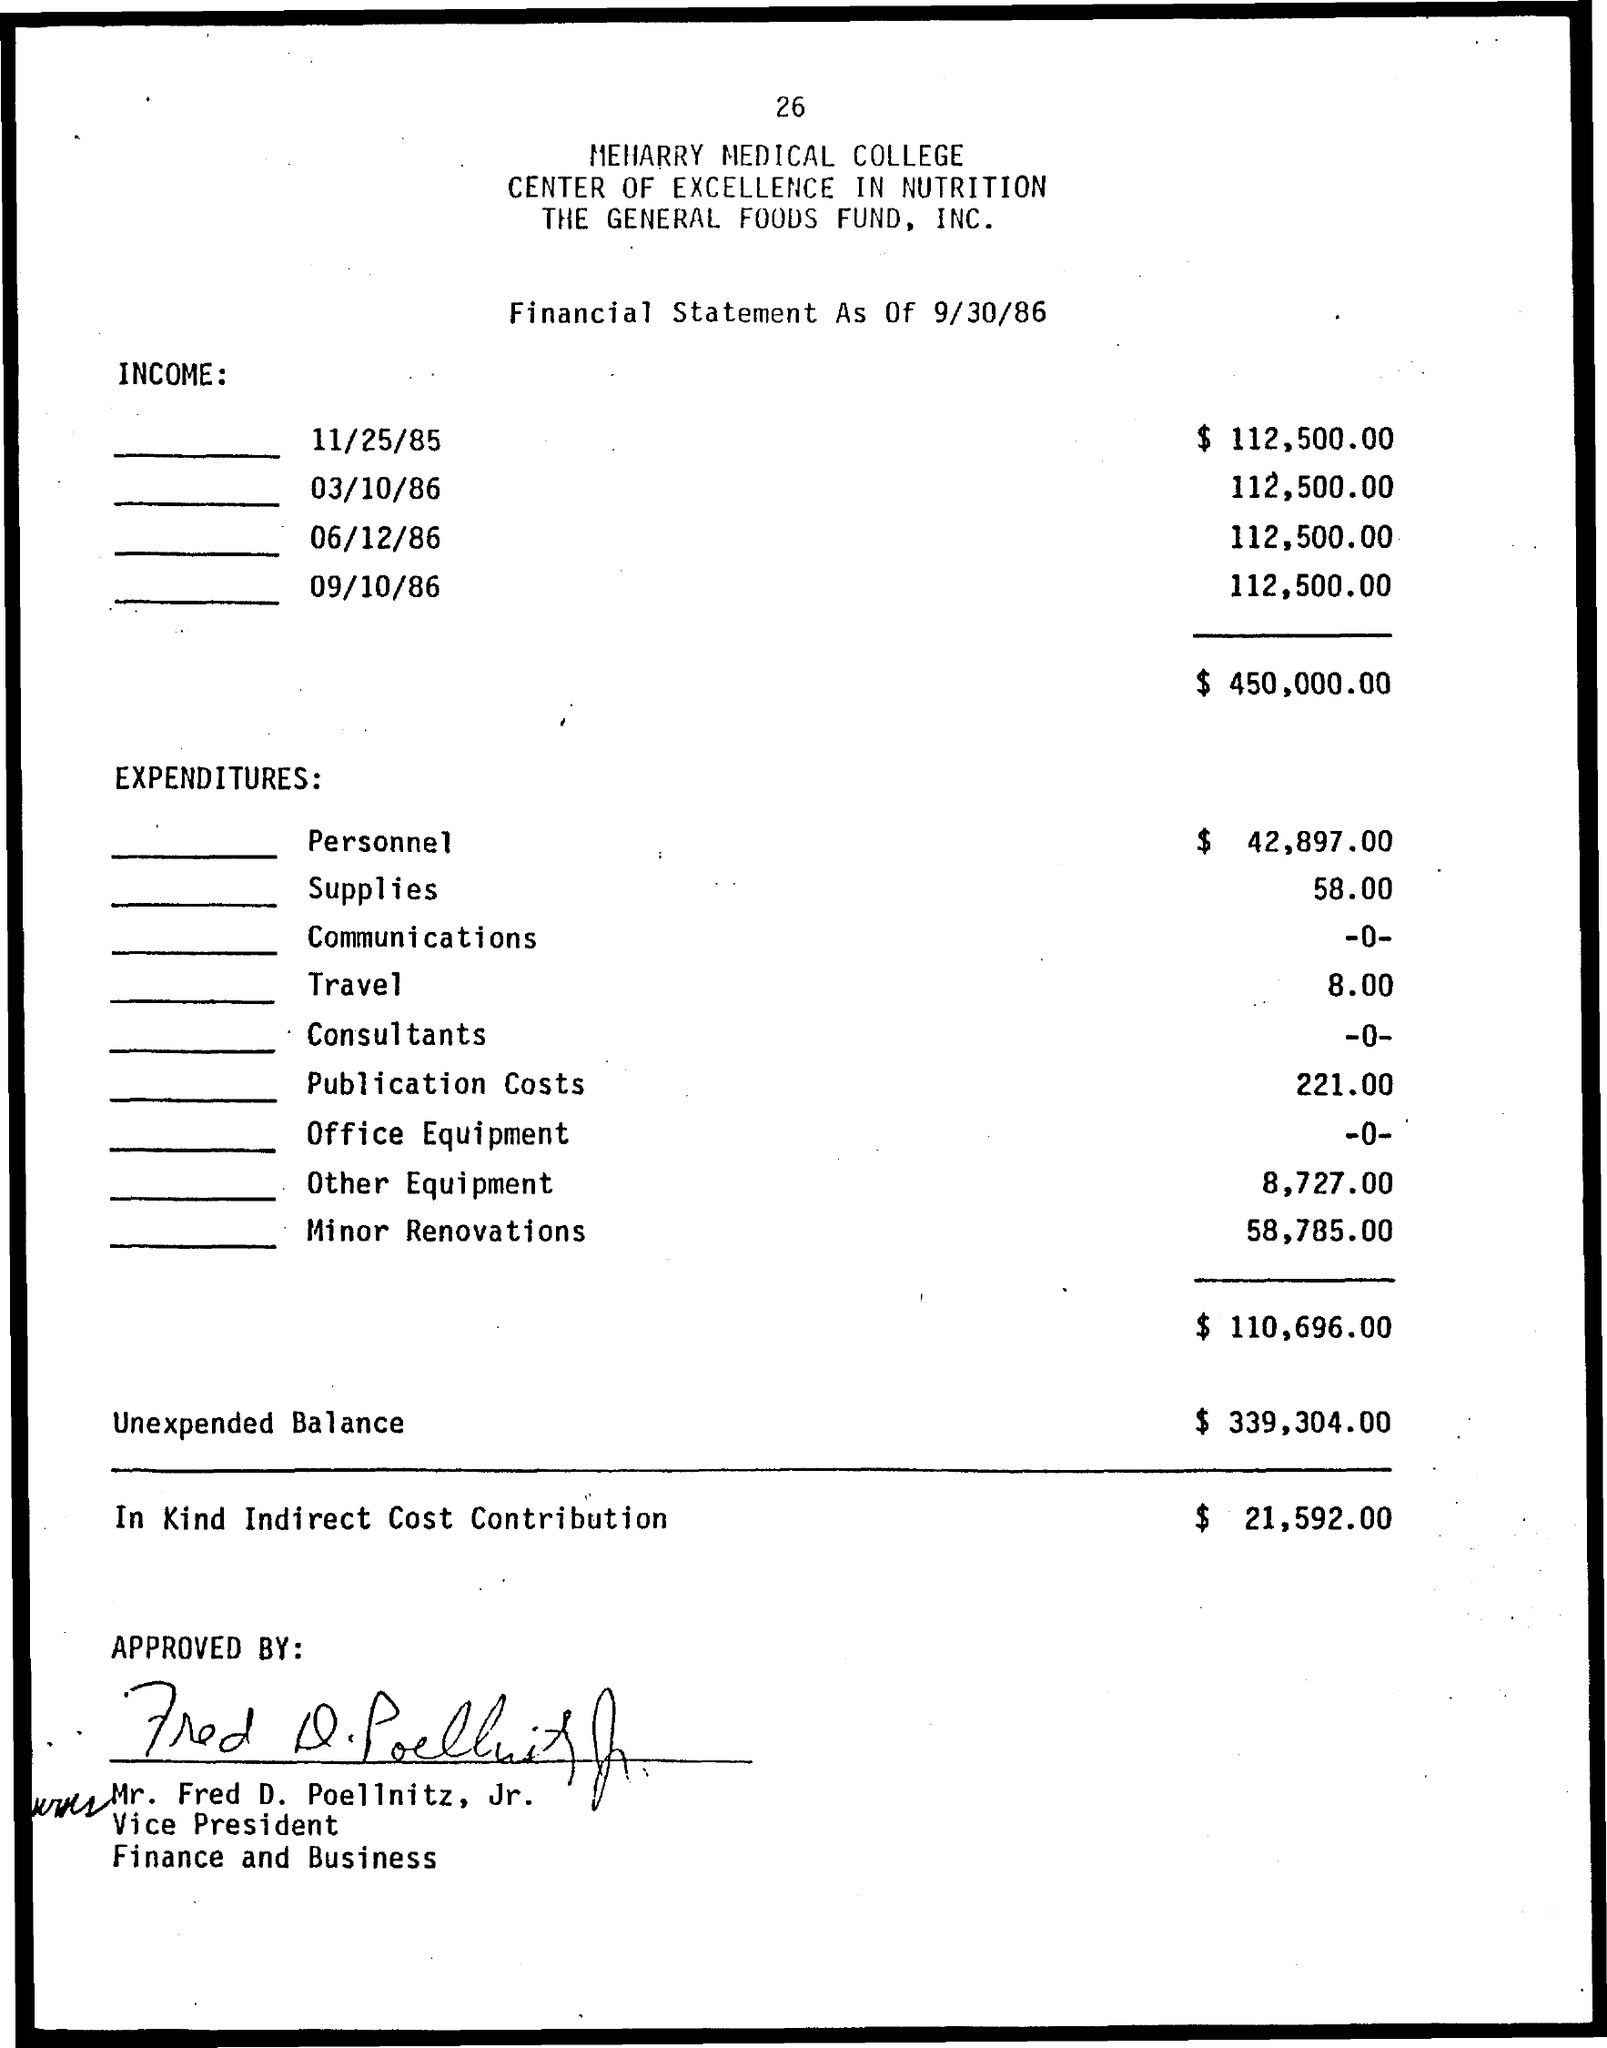How much Total Income ?
Offer a terse response. $ 450.000.00. What is the Supplies Amount ?
Provide a succinct answer. 58.00. How much Travel Amount ?
Make the answer very short. 8.00. How much Unexpended Balance ?
Provide a succinct answer. $ 339,304.00. 